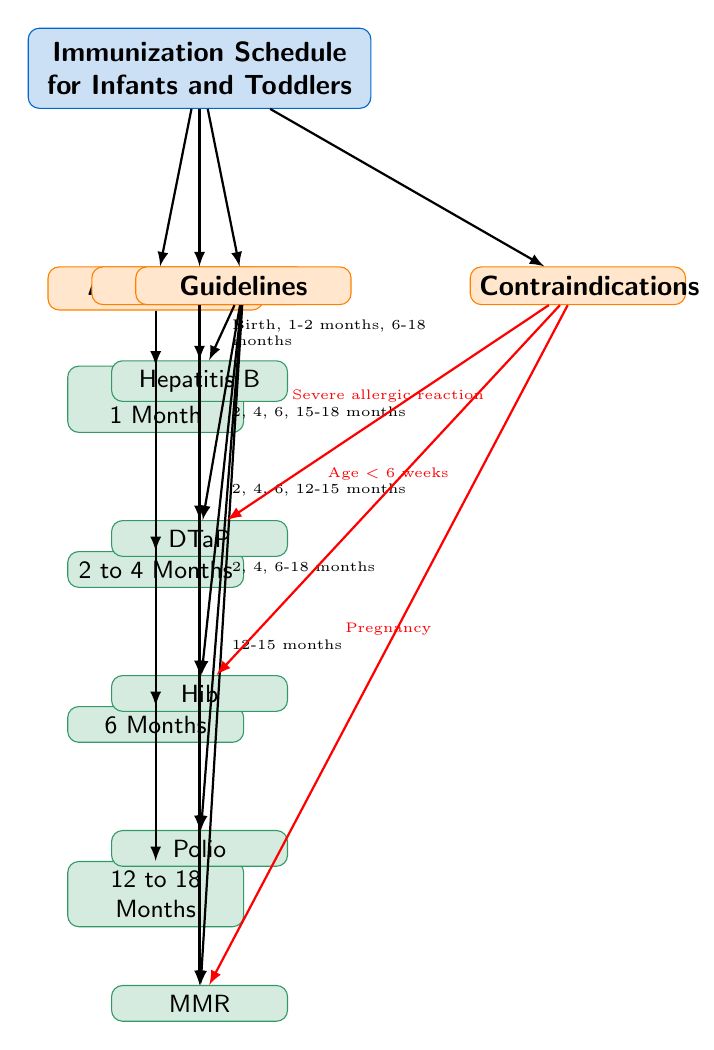What are the four age groups listed in the diagram? The diagram has a section for age groups that includes four specific age ranges: "Birth to 1 Month", "2 to 4 Months", "6 Months", and "12 to 18 Months". These are found in the "Age Group" category.
Answer: Birth to 1 Month, 2 to 4 Months, 6 Months, 12 to 18 Months Which vaccine is recommended at 12 to 15 months? Referring to the "Vaccines" section of the diagram, it shows that the MMR vaccine is recommended at this age. The arrows from the "Guidelines" category to the "MMR" node indicate the appropriate time.
Answer: MMR How many vaccines are listed in the diagram? The "Vaccines" category presents a total of five vaccines: Hepatitis B, DTaP, Hib, Polio, and MMR. By counting the sub-nodes under this category, we reach a total of five.
Answer: 5 Which vaccine has a contraindication related to pregnancy? The "Contraindications" section connects with the "MMR" vaccine. Therefore, the indication highlights that administering this vaccine during pregnancy is a contraindication, as marked with a red edge from the contraindication node to MMR.
Answer: MMR What are the guidelines for the DTaP vaccine? The guidelines for the DTaP vaccine are represented in the diagram as "2, 4, 6, 15-18 months". This information is indicated by the directed edge from the "Guidelines" category to the DTaP node.
Answer: 2, 4, 6, 15-18 months What is the age limitation for the Hib vaccine according to contraindications? The "Contraindications" related to the Hib vaccine in the diagram specifies that it should not be administered to children younger than 6 weeks of age, as indicated. This information requires correlating the node for Hib with its contraindication.
Answer: Age < 6 weeks How many vaccines have guidelines that include the age 2 months? Analyzing the vaccine nodes, both the Hepatitis B and DTaP have guidelines that mention the age 2 months. This requires tracing the guideline connections to see which vaccines include this specific age.
Answer: 2 What is the guideline for the first dose of the Polio vaccine? The diagram establishes that the first dose of the Polio vaccine is given at "2, 4, 6-18 months". This can be found by following the arrows from the "Guidelines" to the Polio node in the diagram.
Answer: 2, 4, 6-18 months 